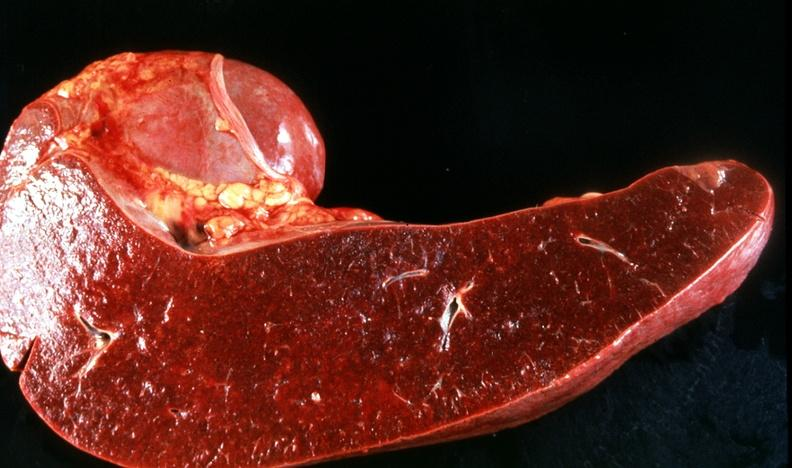does this image show spleen, congestion, congestive heart failure?
Answer the question using a single word or phrase. Yes 